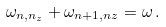Convert formula to latex. <formula><loc_0><loc_0><loc_500><loc_500>\omega _ { n , n _ { z } } + \omega _ { n + 1 , n z } = \omega \, .</formula> 